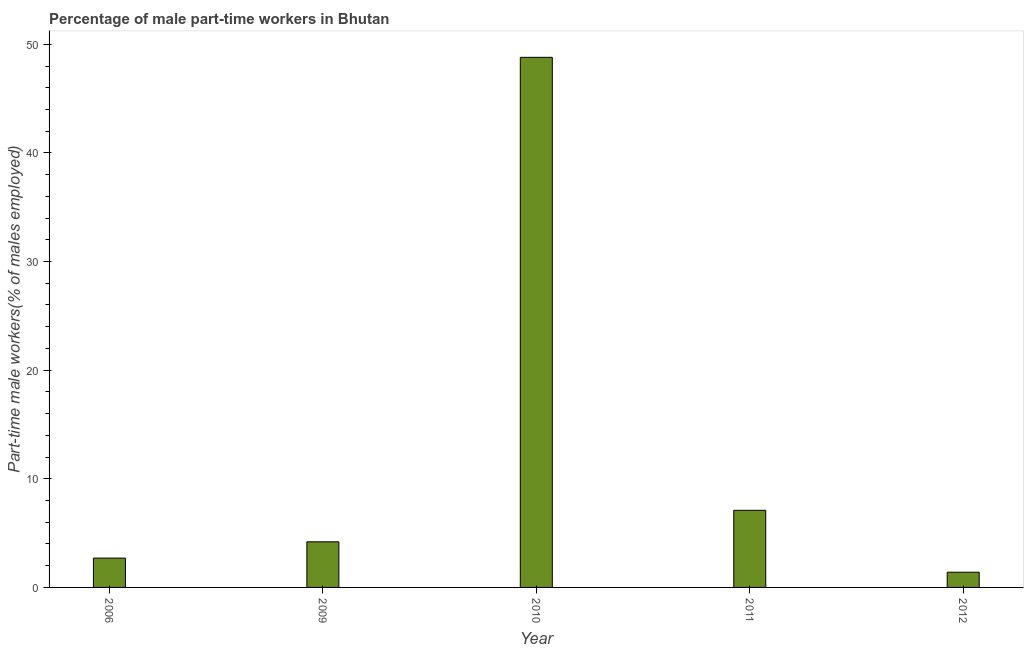What is the title of the graph?
Offer a very short reply. Percentage of male part-time workers in Bhutan. What is the label or title of the Y-axis?
Offer a terse response. Part-time male workers(% of males employed). What is the percentage of part-time male workers in 2006?
Your response must be concise. 2.7. Across all years, what is the maximum percentage of part-time male workers?
Make the answer very short. 48.8. Across all years, what is the minimum percentage of part-time male workers?
Give a very brief answer. 1.4. In which year was the percentage of part-time male workers maximum?
Offer a terse response. 2010. In which year was the percentage of part-time male workers minimum?
Provide a succinct answer. 2012. What is the sum of the percentage of part-time male workers?
Your answer should be compact. 64.2. What is the difference between the percentage of part-time male workers in 2006 and 2010?
Offer a very short reply. -46.1. What is the average percentage of part-time male workers per year?
Offer a terse response. 12.84. What is the median percentage of part-time male workers?
Keep it short and to the point. 4.2. In how many years, is the percentage of part-time male workers greater than 28 %?
Keep it short and to the point. 1. Do a majority of the years between 2009 and 2011 (inclusive) have percentage of part-time male workers greater than 18 %?
Provide a short and direct response. No. What is the ratio of the percentage of part-time male workers in 2006 to that in 2010?
Provide a succinct answer. 0.06. Is the difference between the percentage of part-time male workers in 2009 and 2012 greater than the difference between any two years?
Provide a short and direct response. No. What is the difference between the highest and the second highest percentage of part-time male workers?
Provide a short and direct response. 41.7. What is the difference between the highest and the lowest percentage of part-time male workers?
Offer a terse response. 47.4. How many bars are there?
Give a very brief answer. 5. Are all the bars in the graph horizontal?
Offer a terse response. No. How many years are there in the graph?
Provide a succinct answer. 5. Are the values on the major ticks of Y-axis written in scientific E-notation?
Offer a terse response. No. What is the Part-time male workers(% of males employed) in 2006?
Make the answer very short. 2.7. What is the Part-time male workers(% of males employed) in 2009?
Give a very brief answer. 4.2. What is the Part-time male workers(% of males employed) in 2010?
Make the answer very short. 48.8. What is the Part-time male workers(% of males employed) of 2011?
Your response must be concise. 7.1. What is the Part-time male workers(% of males employed) in 2012?
Make the answer very short. 1.4. What is the difference between the Part-time male workers(% of males employed) in 2006 and 2009?
Ensure brevity in your answer.  -1.5. What is the difference between the Part-time male workers(% of males employed) in 2006 and 2010?
Ensure brevity in your answer.  -46.1. What is the difference between the Part-time male workers(% of males employed) in 2009 and 2010?
Your response must be concise. -44.6. What is the difference between the Part-time male workers(% of males employed) in 2009 and 2011?
Your response must be concise. -2.9. What is the difference between the Part-time male workers(% of males employed) in 2009 and 2012?
Ensure brevity in your answer.  2.8. What is the difference between the Part-time male workers(% of males employed) in 2010 and 2011?
Give a very brief answer. 41.7. What is the difference between the Part-time male workers(% of males employed) in 2010 and 2012?
Ensure brevity in your answer.  47.4. What is the difference between the Part-time male workers(% of males employed) in 2011 and 2012?
Provide a succinct answer. 5.7. What is the ratio of the Part-time male workers(% of males employed) in 2006 to that in 2009?
Give a very brief answer. 0.64. What is the ratio of the Part-time male workers(% of males employed) in 2006 to that in 2010?
Give a very brief answer. 0.06. What is the ratio of the Part-time male workers(% of males employed) in 2006 to that in 2011?
Your response must be concise. 0.38. What is the ratio of the Part-time male workers(% of males employed) in 2006 to that in 2012?
Ensure brevity in your answer.  1.93. What is the ratio of the Part-time male workers(% of males employed) in 2009 to that in 2010?
Make the answer very short. 0.09. What is the ratio of the Part-time male workers(% of males employed) in 2009 to that in 2011?
Your response must be concise. 0.59. What is the ratio of the Part-time male workers(% of males employed) in 2010 to that in 2011?
Your response must be concise. 6.87. What is the ratio of the Part-time male workers(% of males employed) in 2010 to that in 2012?
Provide a succinct answer. 34.86. What is the ratio of the Part-time male workers(% of males employed) in 2011 to that in 2012?
Give a very brief answer. 5.07. 